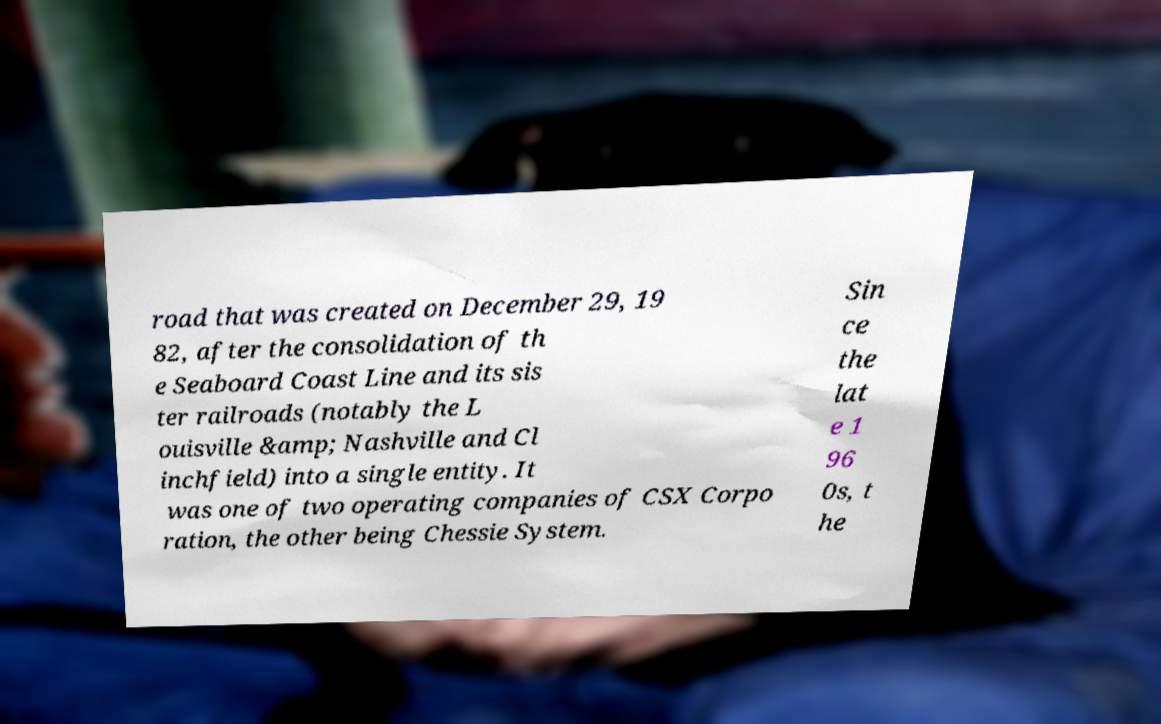Please read and relay the text visible in this image. What does it say? road that was created on December 29, 19 82, after the consolidation of th e Seaboard Coast Line and its sis ter railroads (notably the L ouisville &amp; Nashville and Cl inchfield) into a single entity. It was one of two operating companies of CSX Corpo ration, the other being Chessie System. Sin ce the lat e 1 96 0s, t he 